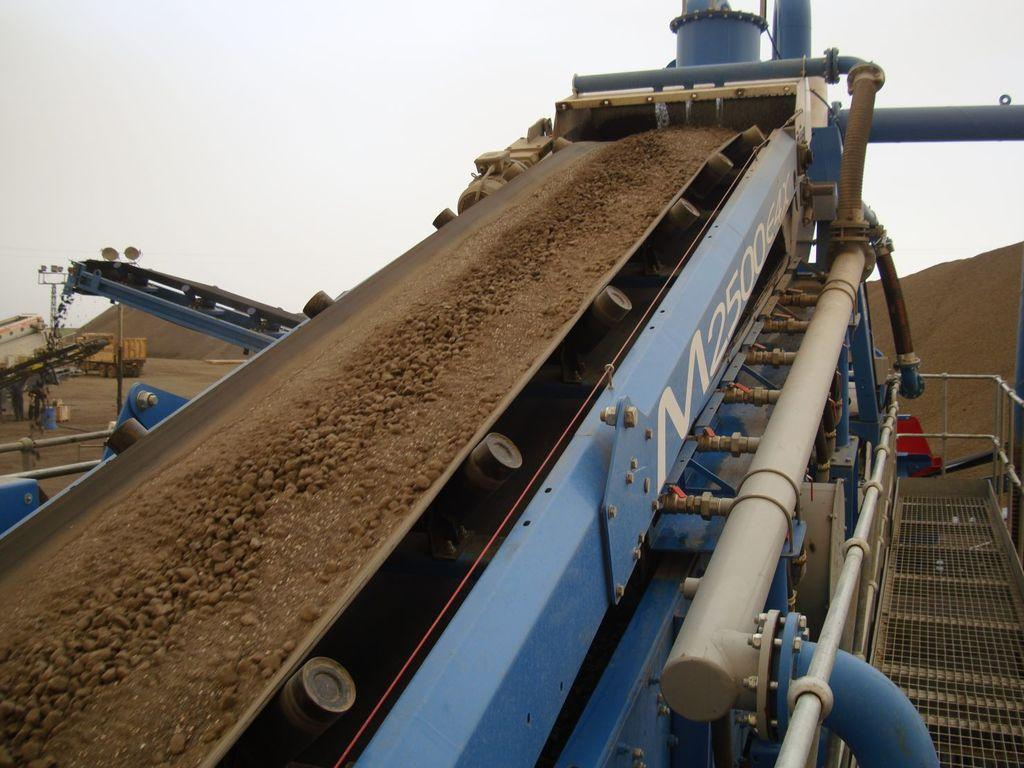What is the main object in the center of the image? There is a machine in the center of the image. What else can be seen in the background of the image? There is a vehicle in the background of the image. What type of terrain is visible in the image? Sand is visible in the image. How many eggs are being used by the expert on the swing in the image? There are no eggs, experts, or swings present in the image. 